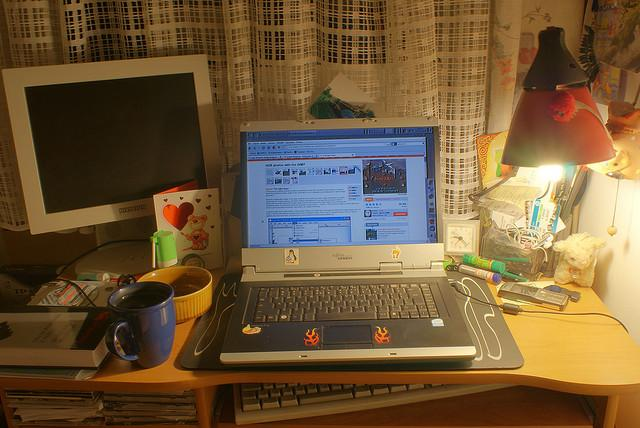How many keys are on a keyboard? 101 